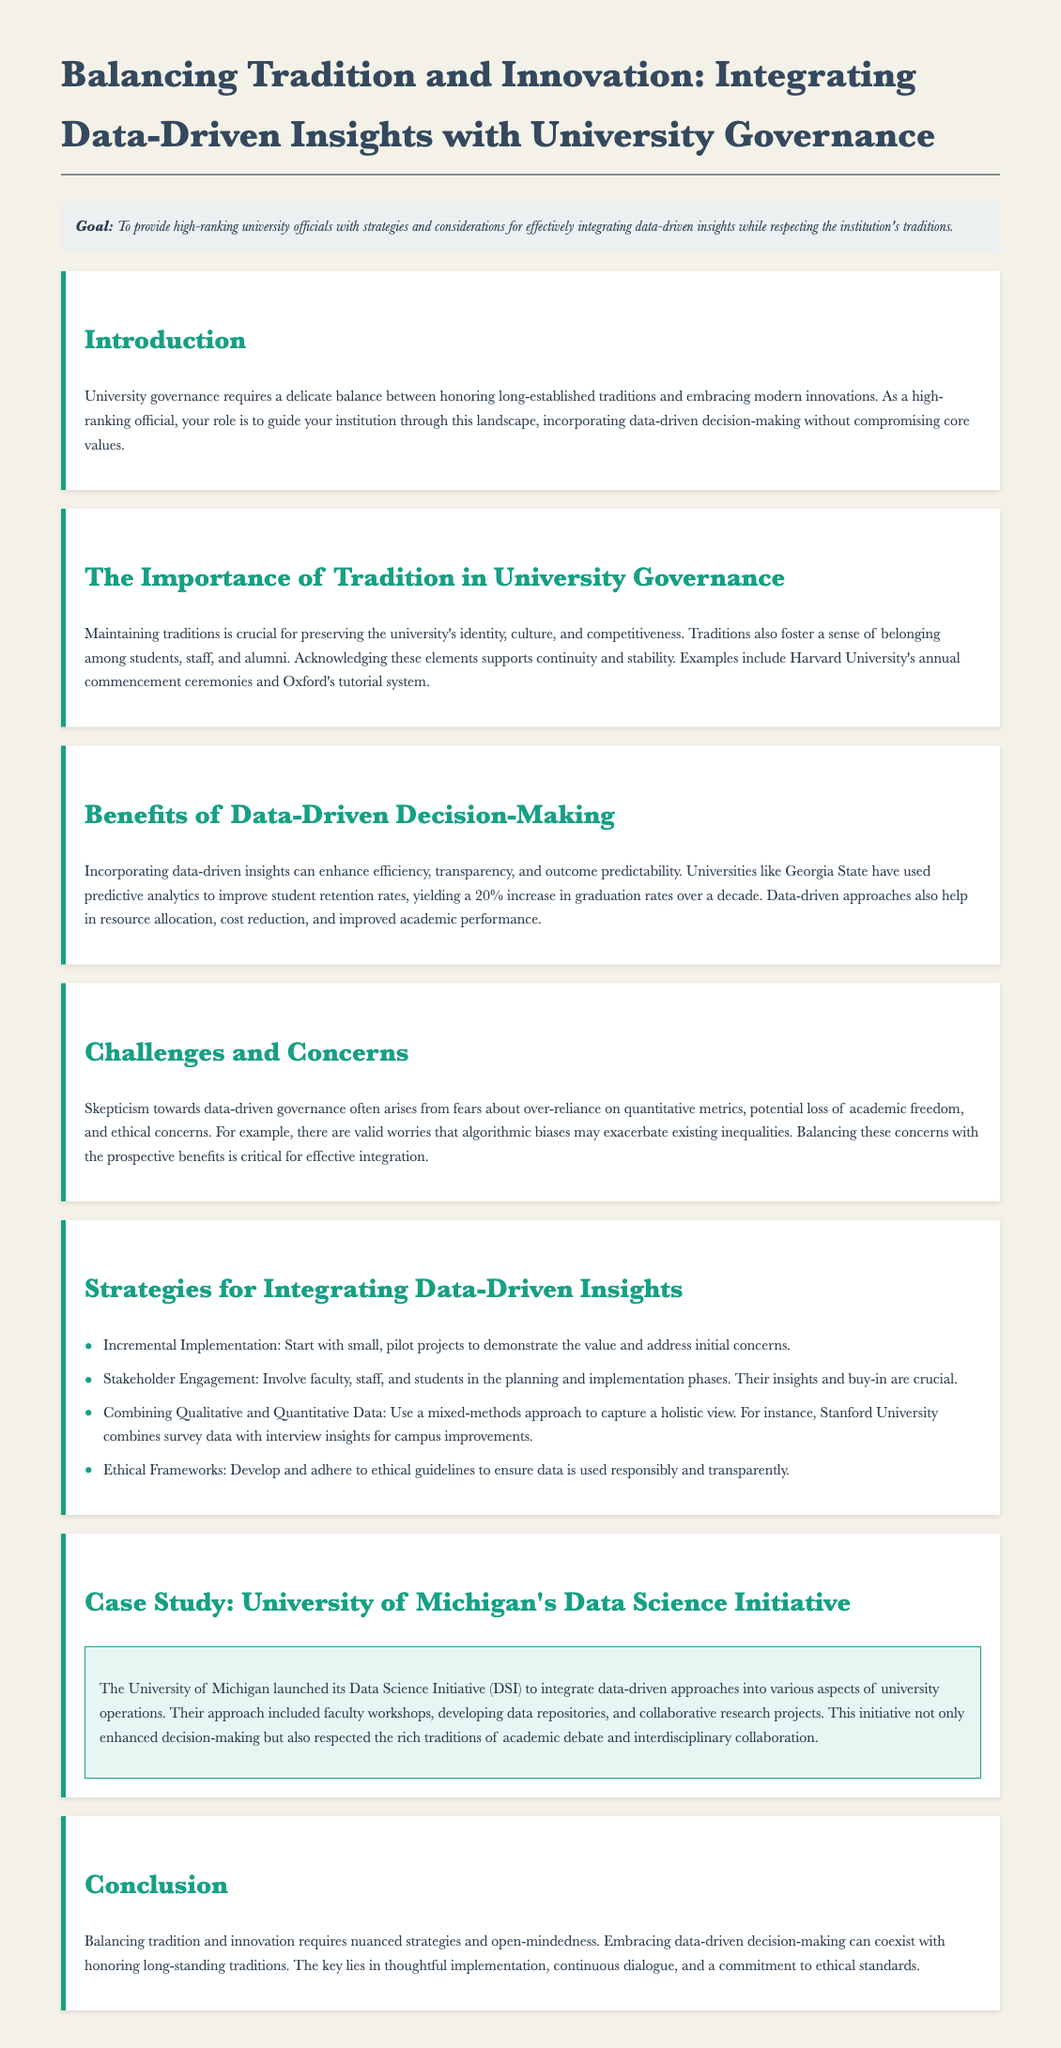What is the goal of the document? The goal is outlined in the document to provide strategies and considerations for integrating data-driven insights while respecting tradition.
Answer: To provide high-ranking university officials with strategies and considerations for effectively integrating data-driven insights while respecting the institution's traditions What university's data science initiative is discussed as a case study? The document cites the University of Michigan as an example of a data-driven initiative.
Answer: University of Michigan What is one benefit of data-driven decision-making mentioned? The document details several benefits, including improving student retention rates, as seen in Georgia State's experience.
Answer: Improve student retention rates What is a challenge of data-driven governance? The document highlights skepticism arising from concerns about over-reliance on quantitative metrics.
Answer: Over-reliance on quantitative metrics What strategy involves starting with small projects? The document suggests using incremental implementation as a strategy for introducing data-driven insights.
Answer: Incremental implementation What approach does Stanford University use for campus improvements? The document mentions that Stanford combines survey data with interview insights for enhancements.
Answer: Combining survey data with interview insights What is crucial to involve in the planning and implementation phases? The document emphasizes the importance of involving faculty, staff, and students in the processes.
Answer: Faculty, staff, and students What ethical aspect is recommended for data usage? Developing and adhering to ethical guidelines is recommended to ensure responsible use of data.
Answer: Ethical guidelines 